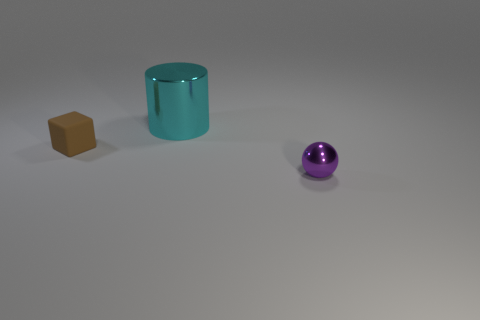Add 1 shiny spheres. How many objects exist? 4 Subtract all big brown metallic spheres. Subtract all brown cubes. How many objects are left? 2 Add 1 purple metal objects. How many purple metal objects are left? 2 Add 3 spheres. How many spheres exist? 4 Subtract 0 blue cylinders. How many objects are left? 3 Subtract all balls. How many objects are left? 2 